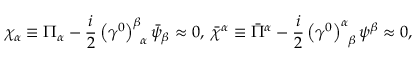<formula> <loc_0><loc_0><loc_500><loc_500>\chi _ { \alpha } \equiv \Pi _ { \alpha } - \frac { i } { 2 } \left ( \gamma ^ { 0 } \right ) _ { \, \alpha } ^ { \beta } \bar { \psi } _ { \beta } \approx 0 , \, \bar { \chi } ^ { \alpha } \equiv \bar { \Pi } ^ { \alpha } - \frac { i } { 2 } \left ( \gamma ^ { 0 } \right ) _ { \, \beta } ^ { \alpha } \psi ^ { \beta } \approx 0 ,</formula> 